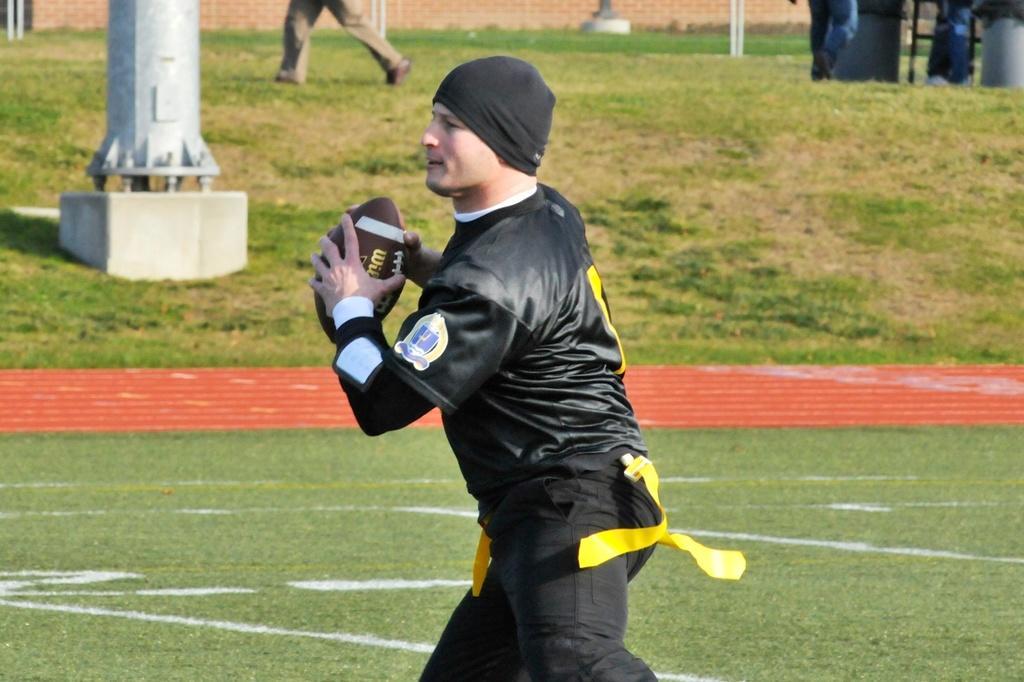Could you give a brief overview of what you see in this image? In the foreground of the image we can see a person holding a ball. On the left side of the image we can see a pole. In the background, we can see some people standing on grass fields, poles and the wall. 